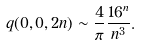<formula> <loc_0><loc_0><loc_500><loc_500>q ( 0 , 0 , 2 n ) \sim \frac { 4 } { \pi } \frac { 1 6 ^ { n } } { n ^ { 3 } } .</formula> 